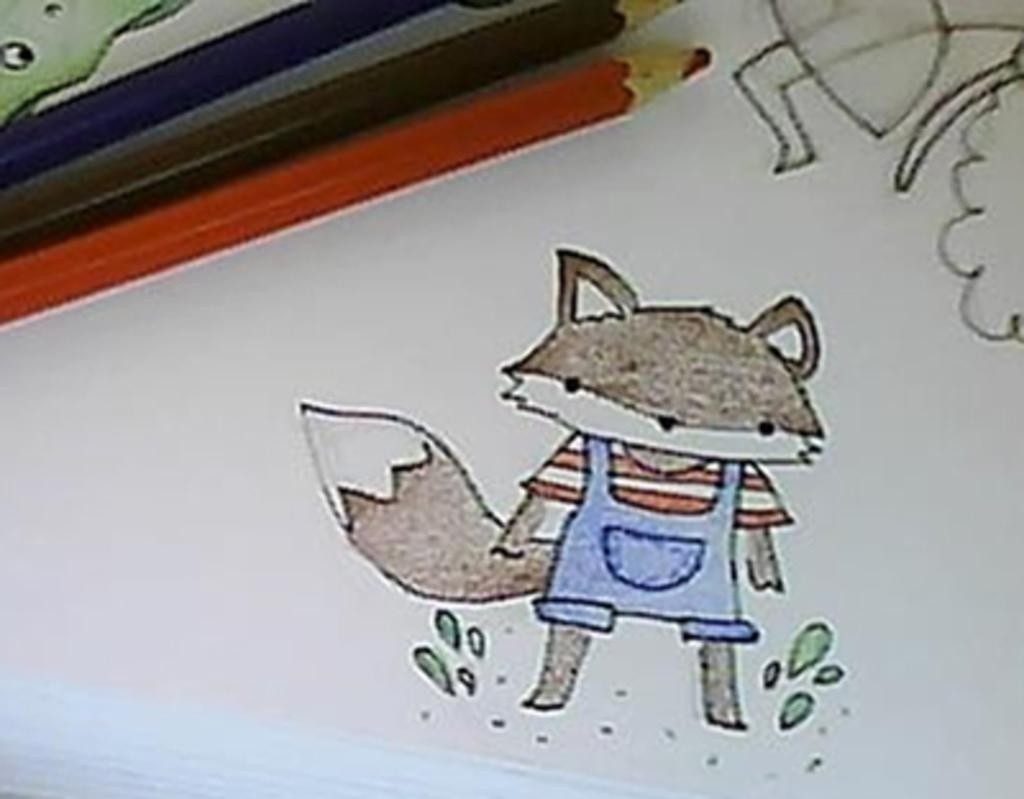What is the main object in the image? There is a white paper in the image. What is depicted on the white paper? The white paper contains sketches of cartoon characters. What tools are visible in the image? There are 3 color pencils in the image. What type of wood is used to make the pan in the image? There is no pan present in the image; it features a white paper with sketches of cartoon characters and color pencils. How many pigs can be seen interacting with the wood in the image? There are no pigs or wood present in the image. 